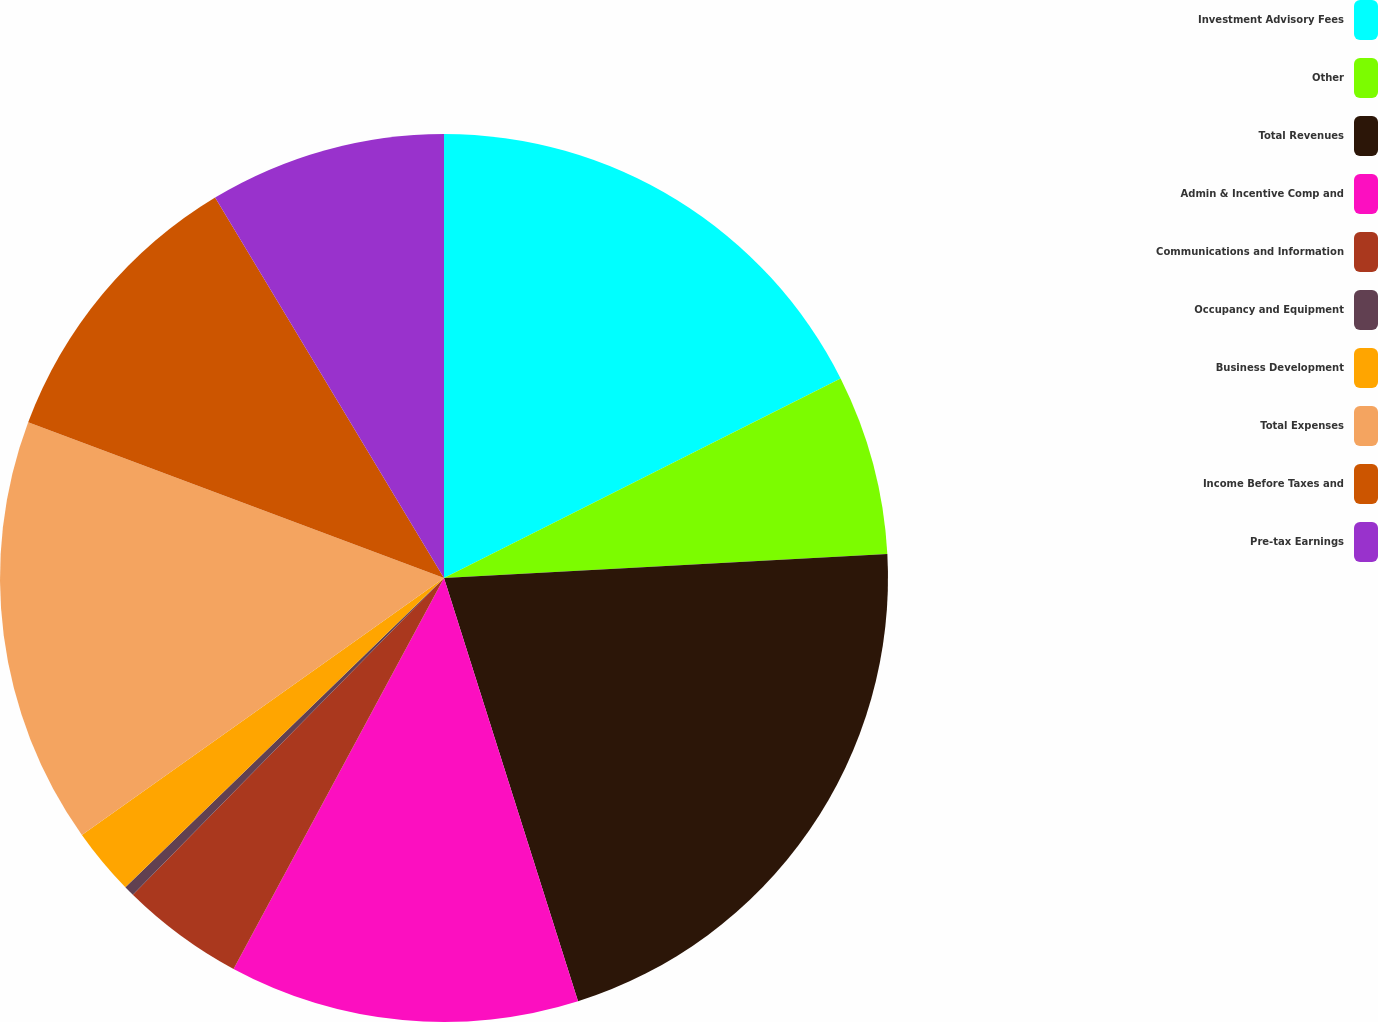Convert chart. <chart><loc_0><loc_0><loc_500><loc_500><pie_chart><fcel>Investment Advisory Fees<fcel>Other<fcel>Total Revenues<fcel>Admin & Incentive Comp and<fcel>Communications and Information<fcel>Occupancy and Equipment<fcel>Business Development<fcel>Total Expenses<fcel>Income Before Taxes and<fcel>Pre-tax Earnings<nl><fcel>17.58%<fcel>6.56%<fcel>20.98%<fcel>12.74%<fcel>4.5%<fcel>0.38%<fcel>2.44%<fcel>15.52%<fcel>10.68%<fcel>8.62%<nl></chart> 